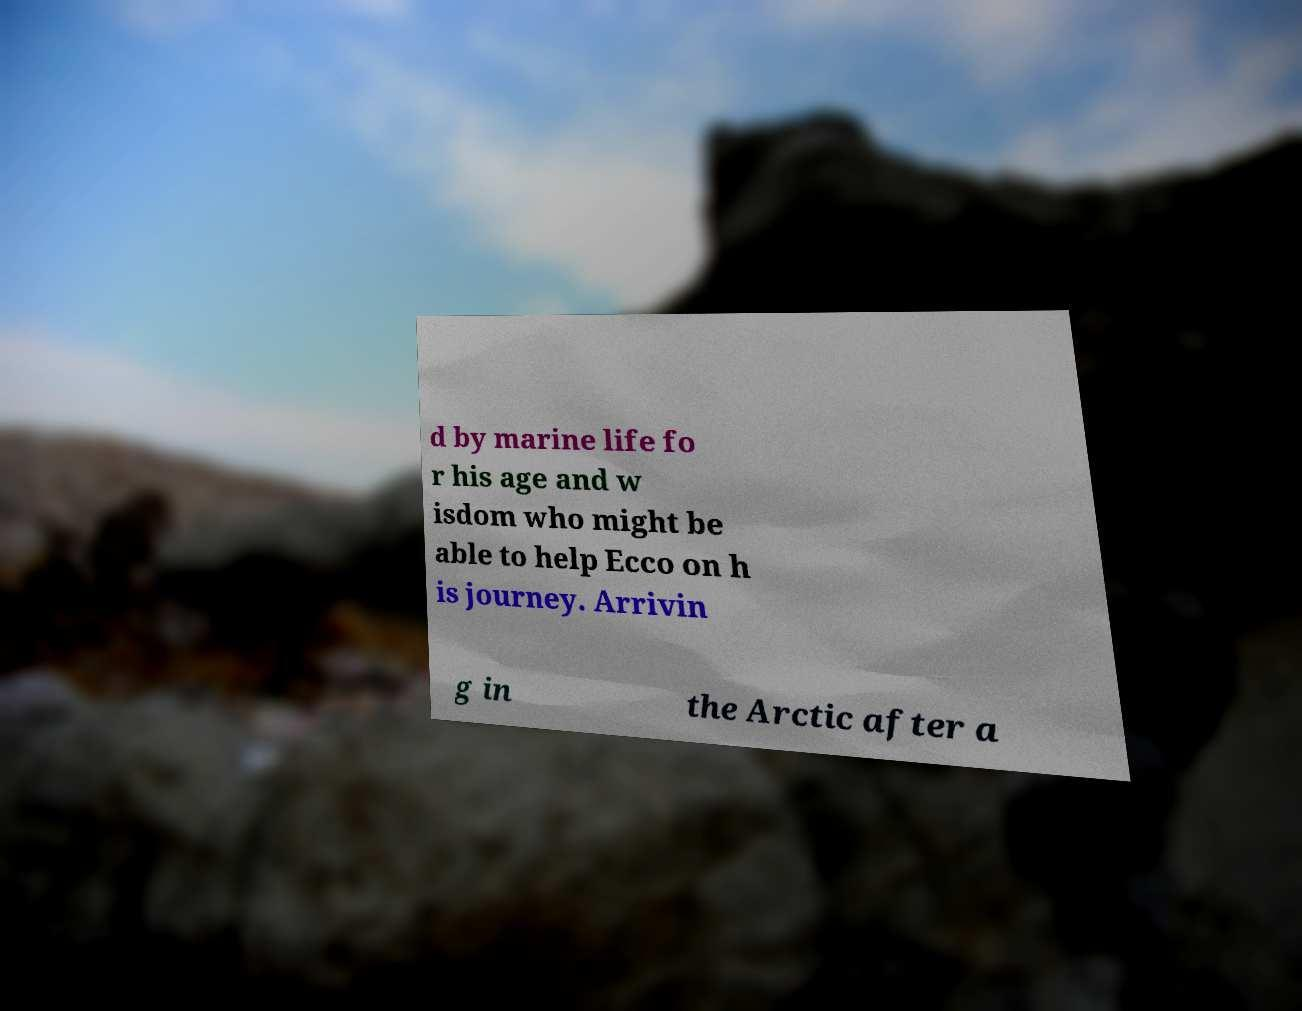Can you accurately transcribe the text from the provided image for me? d by marine life fo r his age and w isdom who might be able to help Ecco on h is journey. Arrivin g in the Arctic after a 